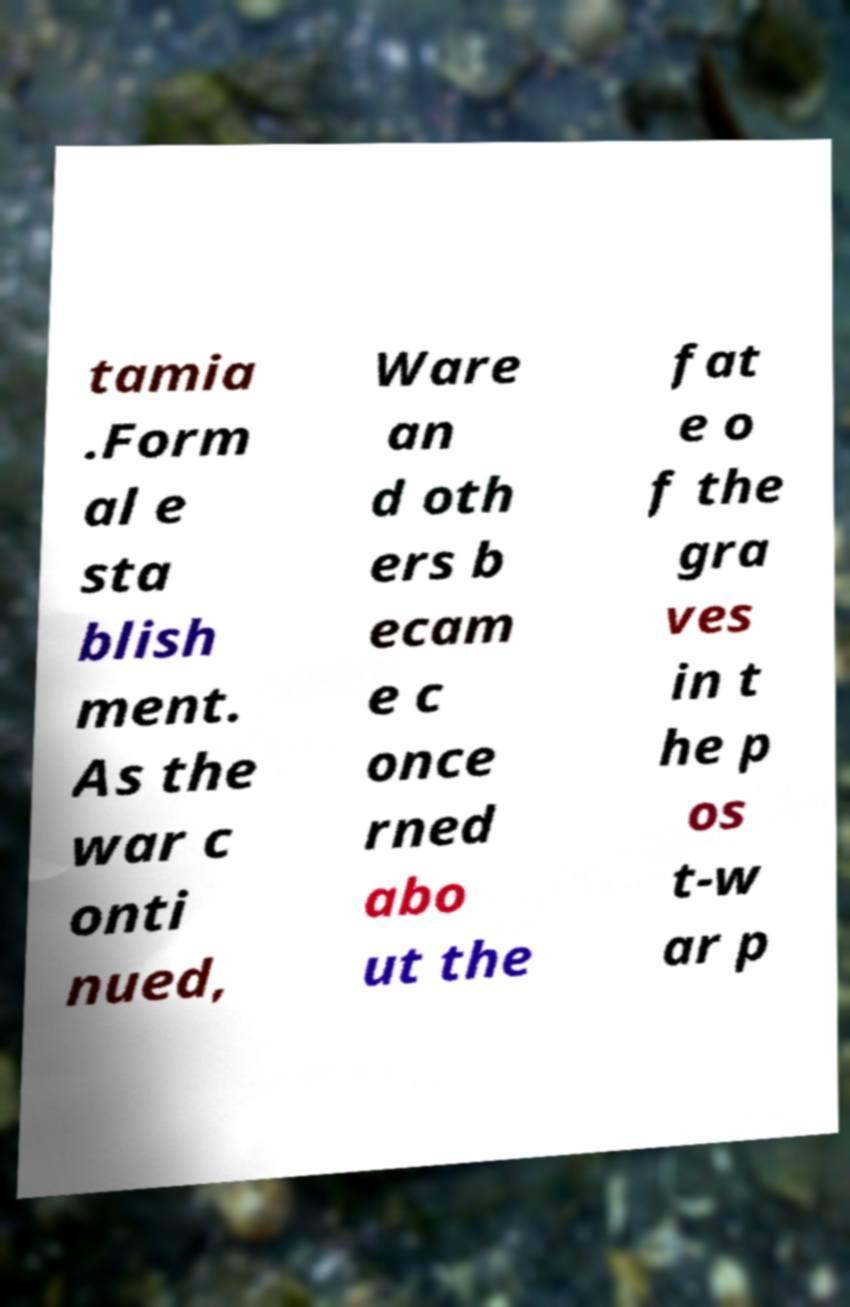Could you assist in decoding the text presented in this image and type it out clearly? tamia .Form al e sta blish ment. As the war c onti nued, Ware an d oth ers b ecam e c once rned abo ut the fat e o f the gra ves in t he p os t-w ar p 